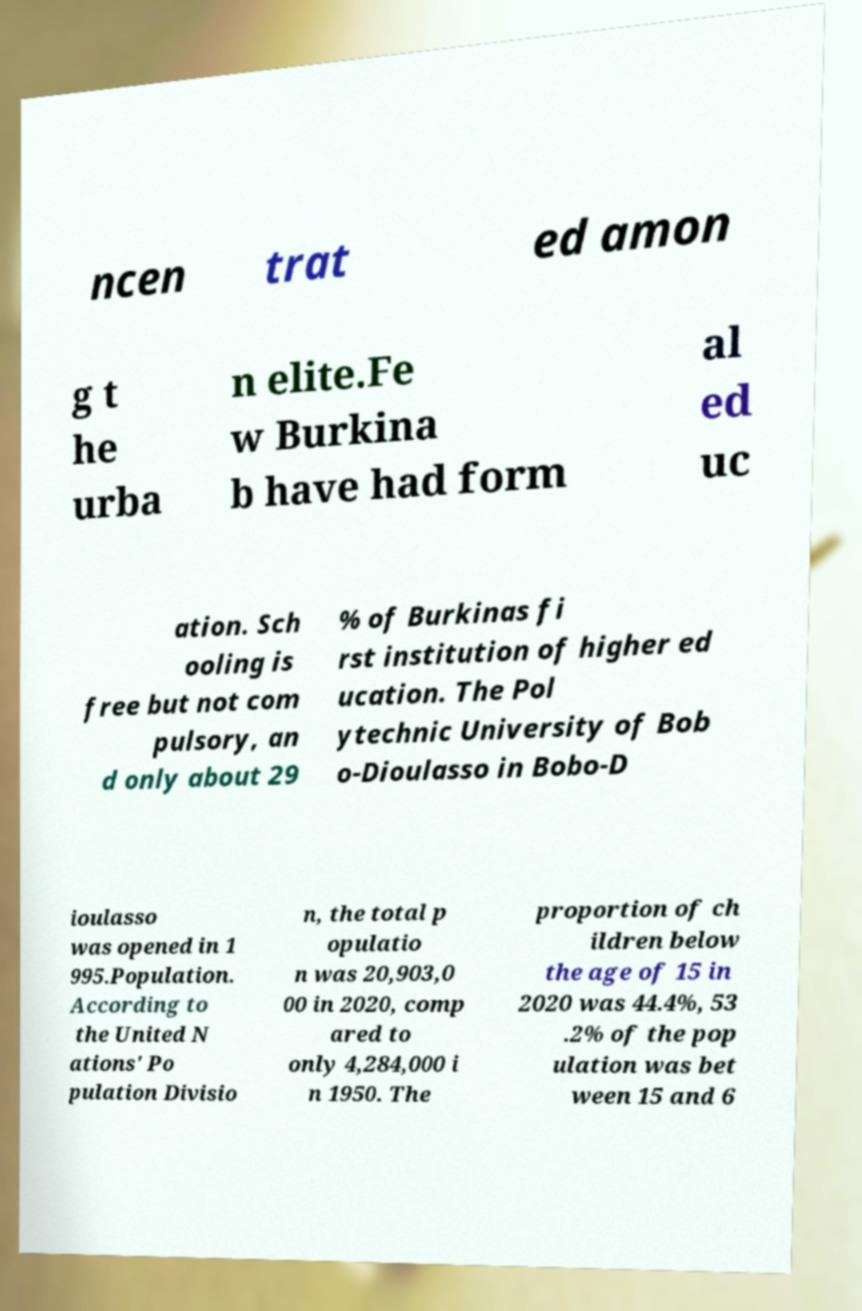I need the written content from this picture converted into text. Can you do that? ncen trat ed amon g t he urba n elite.Fe w Burkina b have had form al ed uc ation. Sch ooling is free but not com pulsory, an d only about 29 % of Burkinas fi rst institution of higher ed ucation. The Pol ytechnic University of Bob o-Dioulasso in Bobo-D ioulasso was opened in 1 995.Population. According to the United N ations' Po pulation Divisio n, the total p opulatio n was 20,903,0 00 in 2020, comp ared to only 4,284,000 i n 1950. The proportion of ch ildren below the age of 15 in 2020 was 44.4%, 53 .2% of the pop ulation was bet ween 15 and 6 